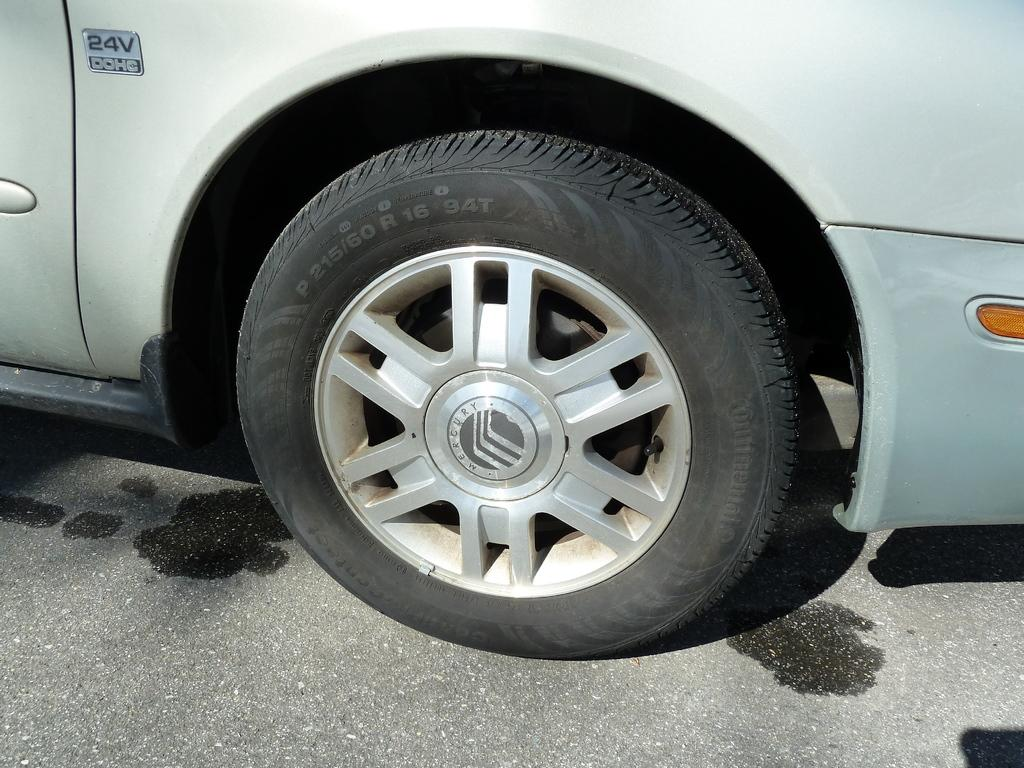What is the main subject of the image? There is a vehicle in the image. Where is the vehicle located? The vehicle is on the road. What are some features of the vehicle? The vehicle has wheels, a small headlight on the right side, and a door on the left side. How many feet are visible inside the vehicle in the image? There are no feet visible inside the vehicle in the image. What type of club is associated with the vehicle in the image? There is no club associated with the vehicle in the image. 